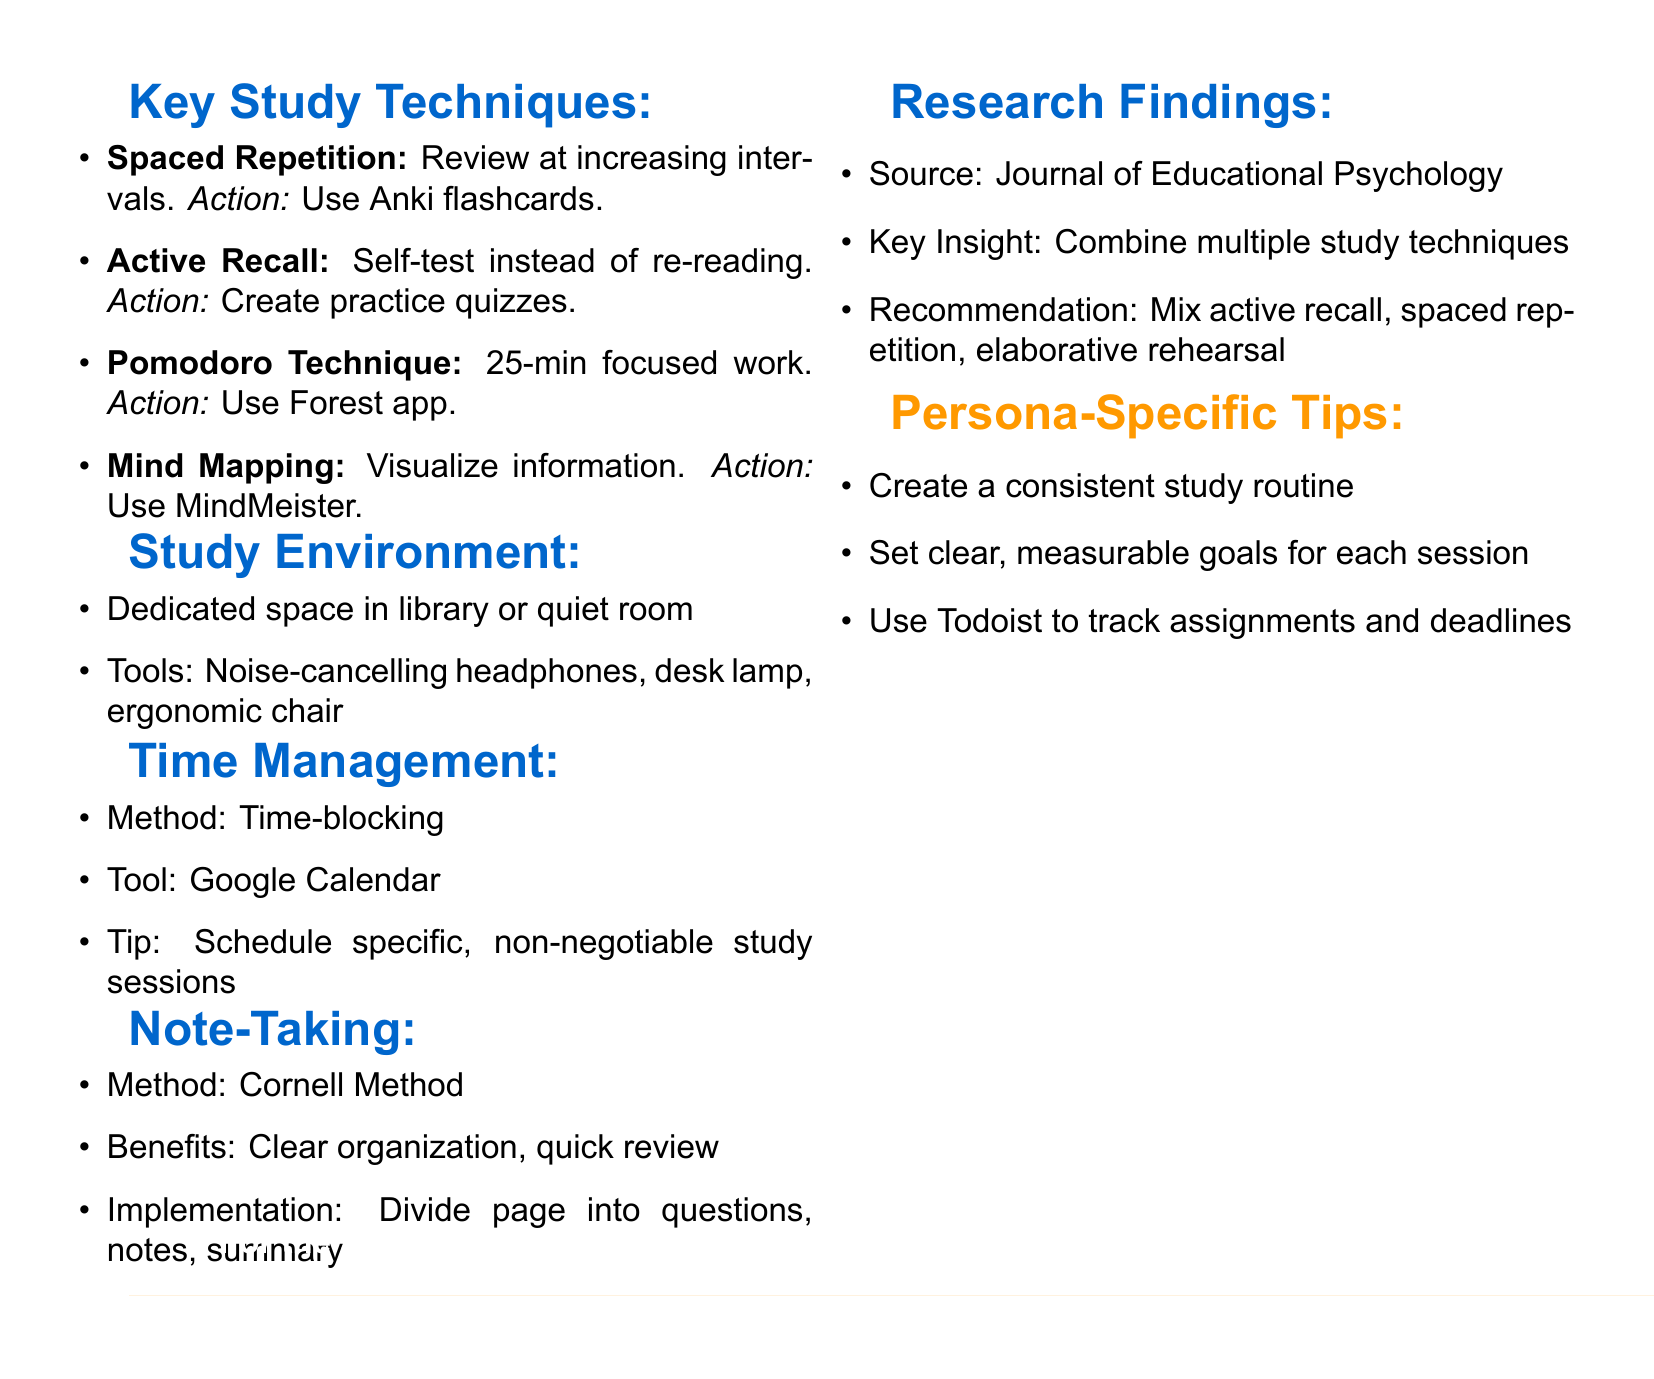What is the main focus of this document? The document summarizes effective study techniques tailored for ambitious students, outlining actionable strategies to enhance study effectiveness.
Answer: Effective study techniques What technique uses hand-written questions for self-testing? The document discusses several study techniques, specifically highlighting a method for self-testing that can be conducted through practice quizzes.
Answer: Active Recall Which app is recommended for tracking focused work sessions? The document provides specific applications for study techniques, including one that helps to manage focused work time effectively.
Answer: Forest app What method is suggested for time management? The document specifies a time management approach that involves scheduling specific study times to enhance productivity.
Answer: Time-blocking What is the Cornell Method used for? This method is mentioned in the document as a way to organize notes effectively, facilitating easier review.
Answer: Note-taking What tool is recommended for creating visual representations? The document mentions a specific application for creating mind maps, which aids in visualizing complex information.
Answer: MindMeister Which research source is cited in the document? The document references a specific academic source that informs its findings on study techniques.
Answer: Journal of Educational Psychology According to the document, what should you minimize to create a consistent study routine? The document emphasizes the importance of creating a consistent routine for study sessions, advising on what to limit in that context.
Answer: Adaptation What are the benefits of the Cornell Method listed in the document? The document outlines advantages of this note-taking method, which enhance clarity and speed of review.
Answer: Organizes information clearly, facilitates quick review 